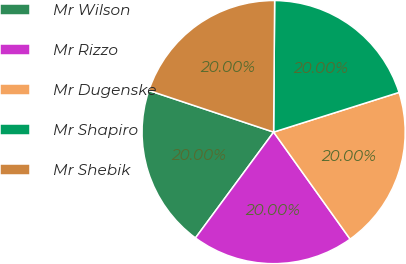Convert chart. <chart><loc_0><loc_0><loc_500><loc_500><pie_chart><fcel>Mr Wilson<fcel>Mr Rizzo<fcel>Mr Dugenske<fcel>Mr Shapiro<fcel>Mr Shebik<nl><fcel>20.0%<fcel>20.0%<fcel>20.0%<fcel>20.0%<fcel>20.0%<nl></chart> 